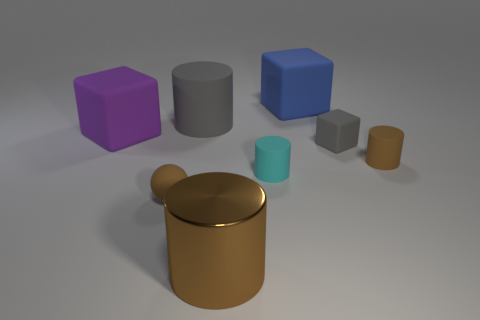There is a purple object that is the same shape as the tiny gray thing; what is it made of?
Your answer should be compact. Rubber. Are there any other things that are made of the same material as the big purple object?
Your response must be concise. Yes. Do the big matte cylinder and the rubber sphere have the same color?
Keep it short and to the point. No. What is the shape of the purple object that is the same material as the gray cylinder?
Offer a terse response. Cube. What number of gray objects are the same shape as the cyan rubber thing?
Offer a terse response. 1. There is a tiny brown object right of the big cylinder behind the big purple cube; what is its shape?
Provide a short and direct response. Cylinder. Does the cylinder in front of the cyan matte cylinder have the same size as the large purple object?
Provide a succinct answer. Yes. How big is the matte block that is in front of the large blue matte object and on the right side of the small cyan matte thing?
Offer a very short reply. Small. How many balls have the same size as the gray rubber cylinder?
Your response must be concise. 0. There is a gray rubber object in front of the purple rubber block; what number of cyan rubber cylinders are to the right of it?
Offer a very short reply. 0. 